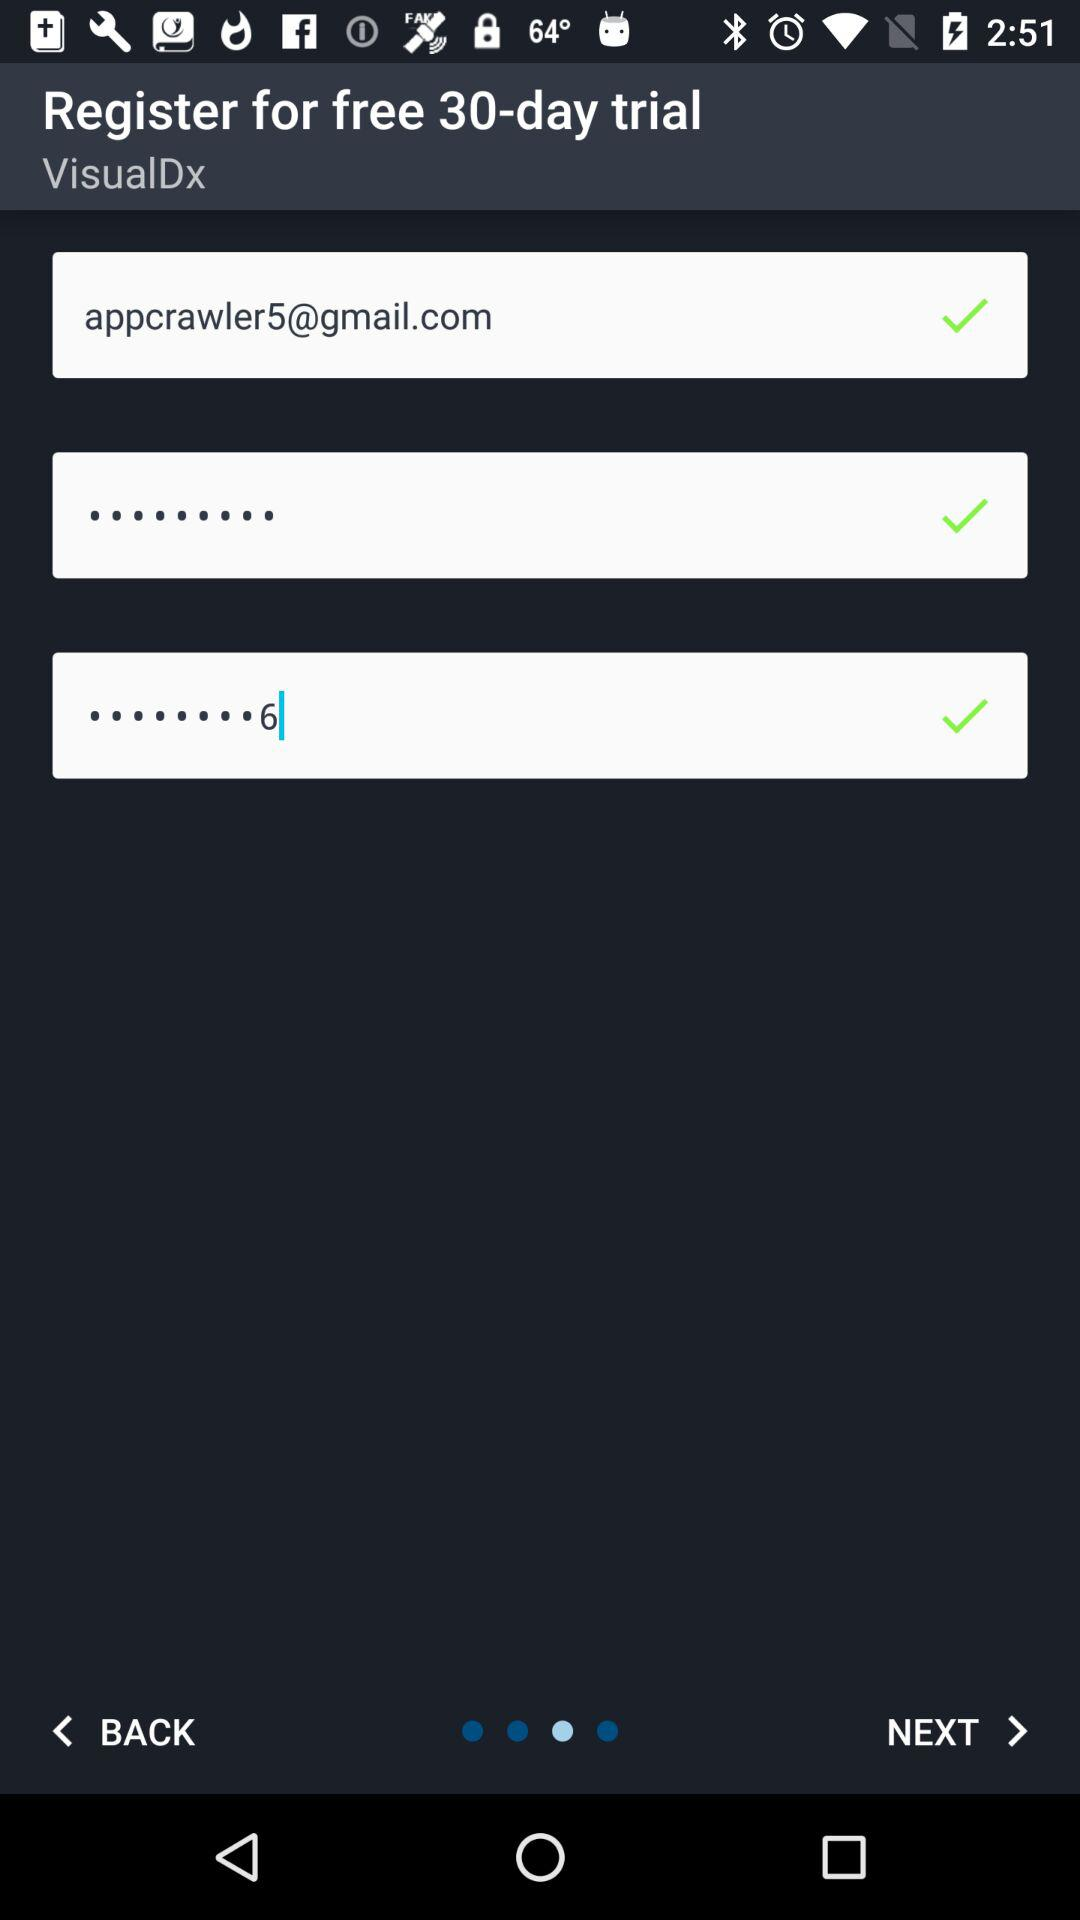What is the entered email address? The entered email address is appcrawler5@gmail.com. 